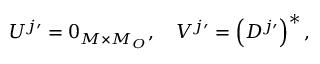<formula> <loc_0><loc_0><loc_500><loc_500>U ^ { j \prime } = 0 _ { M \times M _ { O } } , \quad V ^ { j \prime } = \left ( D ^ { j \prime } \right ) ^ { * } ,</formula> 